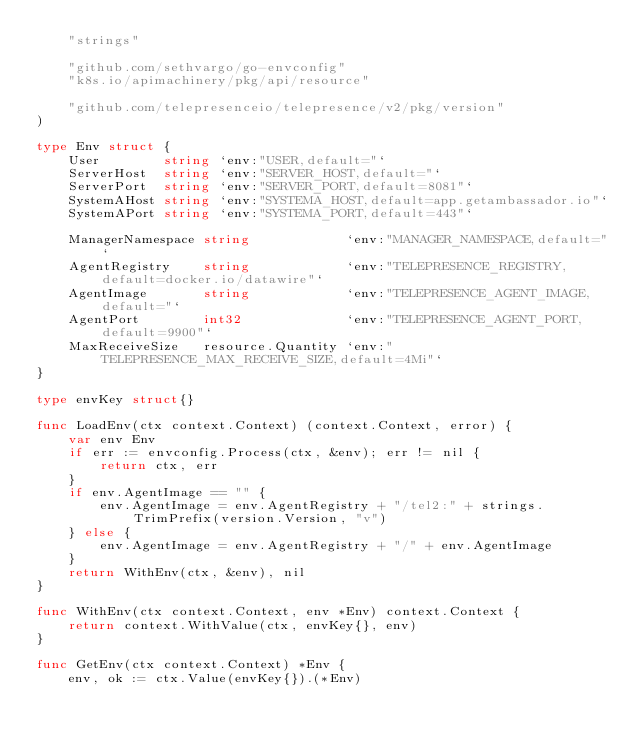Convert code to text. <code><loc_0><loc_0><loc_500><loc_500><_Go_>	"strings"

	"github.com/sethvargo/go-envconfig"
	"k8s.io/apimachinery/pkg/api/resource"

	"github.com/telepresenceio/telepresence/v2/pkg/version"
)

type Env struct {
	User        string `env:"USER,default="`
	ServerHost  string `env:"SERVER_HOST,default="`
	ServerPort  string `env:"SERVER_PORT,default=8081"`
	SystemAHost string `env:"SYSTEMA_HOST,default=app.getambassador.io"`
	SystemAPort string `env:"SYSTEMA_PORT,default=443"`

	ManagerNamespace string            `env:"MANAGER_NAMESPACE,default="`
	AgentRegistry    string            `env:"TELEPRESENCE_REGISTRY,default=docker.io/datawire"`
	AgentImage       string            `env:"TELEPRESENCE_AGENT_IMAGE,default="`
	AgentPort        int32             `env:"TELEPRESENCE_AGENT_PORT,default=9900"`
	MaxReceiveSize   resource.Quantity `env:"TELEPRESENCE_MAX_RECEIVE_SIZE,default=4Mi"`
}

type envKey struct{}

func LoadEnv(ctx context.Context) (context.Context, error) {
	var env Env
	if err := envconfig.Process(ctx, &env); err != nil {
		return ctx, err
	}
	if env.AgentImage == "" {
		env.AgentImage = env.AgentRegistry + "/tel2:" + strings.TrimPrefix(version.Version, "v")
	} else {
		env.AgentImage = env.AgentRegistry + "/" + env.AgentImage
	}
	return WithEnv(ctx, &env), nil
}

func WithEnv(ctx context.Context, env *Env) context.Context {
	return context.WithValue(ctx, envKey{}, env)
}

func GetEnv(ctx context.Context) *Env {
	env, ok := ctx.Value(envKey{}).(*Env)</code> 